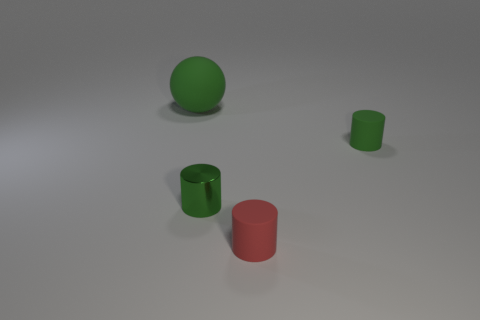Add 1 small blue shiny things. How many objects exist? 5 Subtract all spheres. How many objects are left? 3 Add 4 tiny rubber things. How many tiny rubber things are left? 6 Add 2 red metal blocks. How many red metal blocks exist? 2 Subtract 2 green cylinders. How many objects are left? 2 Subtract all small red blocks. Subtract all tiny green matte objects. How many objects are left? 3 